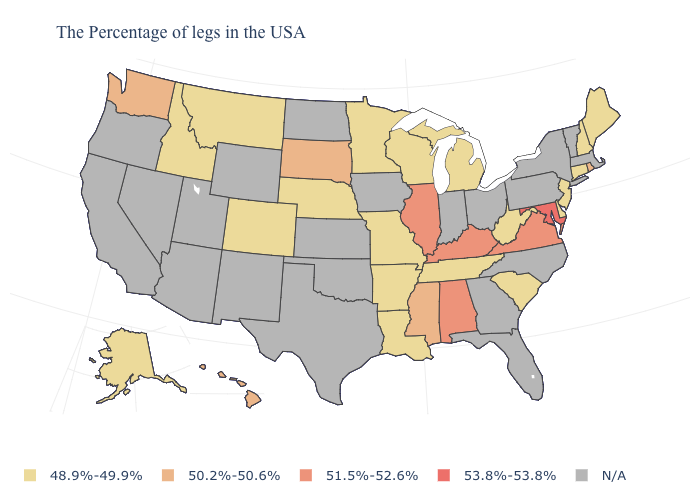Does South Carolina have the lowest value in the USA?
Quick response, please. Yes. What is the value of South Dakota?
Short answer required. 50.2%-50.6%. Among the states that border Massachusetts , which have the lowest value?
Concise answer only. New Hampshire, Connecticut. Among the states that border Pennsylvania , which have the lowest value?
Short answer required. New Jersey, Delaware, West Virginia. What is the value of Nevada?
Write a very short answer. N/A. Among the states that border Oregon , which have the lowest value?
Give a very brief answer. Idaho. What is the value of California?
Answer briefly. N/A. Which states have the lowest value in the USA?
Answer briefly. Maine, New Hampshire, Connecticut, New Jersey, Delaware, South Carolina, West Virginia, Michigan, Tennessee, Wisconsin, Louisiana, Missouri, Arkansas, Minnesota, Nebraska, Colorado, Montana, Idaho, Alaska. Name the states that have a value in the range N/A?
Short answer required. Massachusetts, Vermont, New York, Pennsylvania, North Carolina, Ohio, Florida, Georgia, Indiana, Iowa, Kansas, Oklahoma, Texas, North Dakota, Wyoming, New Mexico, Utah, Arizona, Nevada, California, Oregon. What is the lowest value in states that border Missouri?
Give a very brief answer. 48.9%-49.9%. What is the value of Virginia?
Short answer required. 51.5%-52.6%. How many symbols are there in the legend?
Give a very brief answer. 5. What is the value of Delaware?
Be succinct. 48.9%-49.9%. What is the highest value in the MidWest ?
Keep it brief. 51.5%-52.6%. 